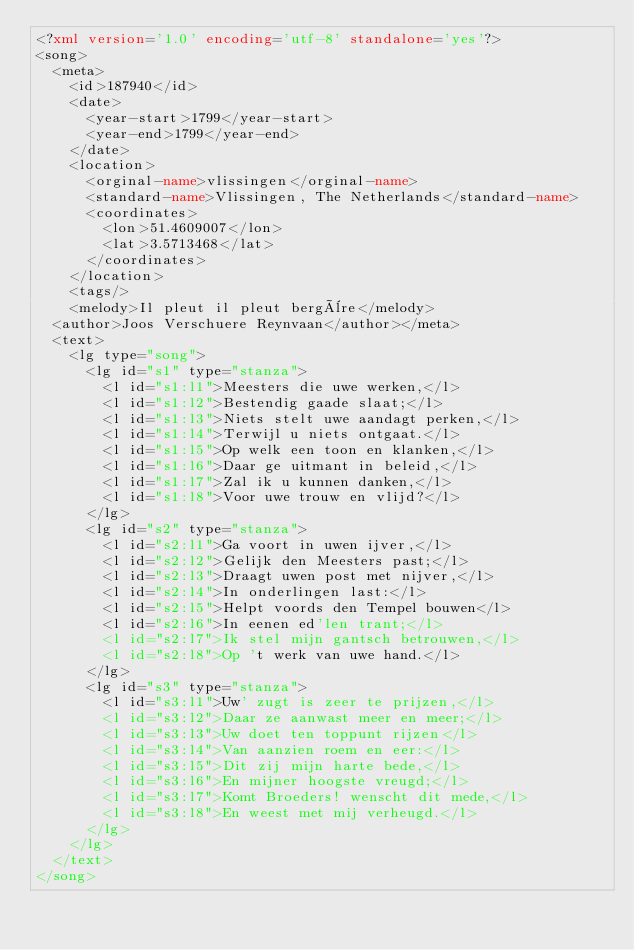<code> <loc_0><loc_0><loc_500><loc_500><_XML_><?xml version='1.0' encoding='utf-8' standalone='yes'?>
<song>
  <meta>
    <id>187940</id>
    <date>
      <year-start>1799</year-start>
      <year-end>1799</year-end>
    </date>
    <location>
      <orginal-name>vlissingen</orginal-name>
      <standard-name>Vlissingen, The Netherlands</standard-name>
      <coordinates>
        <lon>51.4609007</lon>
        <lat>3.5713468</lat>
      </coordinates>
    </location>
    <tags/>
    <melody>Il pleut il pleut bergère</melody>
  <author>Joos Verschuere Reynvaan</author></meta>
  <text>
    <lg type="song">
      <lg id="s1" type="stanza">
        <l id="s1:l1">Meesters die uwe werken,</l>
        <l id="s1:l2">Bestendig gaade slaat;</l>
        <l id="s1:l3">Niets stelt uwe aandagt perken,</l>
        <l id="s1:l4">Terwijl u niets ontgaat.</l>
        <l id="s1:l5">Op welk een toon en klanken,</l>
        <l id="s1:l6">Daar ge uitmant in beleid,</l>
        <l id="s1:l7">Zal ik u kunnen danken,</l>
        <l id="s1:l8">Voor uwe trouw en vlijd?</l>
      </lg>
      <lg id="s2" type="stanza">
        <l id="s2:l1">Ga voort in uwen ijver,</l>
        <l id="s2:l2">Gelijk den Meesters past;</l>
        <l id="s2:l3">Draagt uwen post met nijver,</l>
        <l id="s2:l4">In onderlingen last:</l>
        <l id="s2:l5">Helpt voords den Tempel bouwen</l>
        <l id="s2:l6">In eenen ed'len trant;</l>
        <l id="s2:l7">Ik stel mijn gantsch betrouwen,</l>
        <l id="s2:l8">Op 't werk van uwe hand.</l>
      </lg>
      <lg id="s3" type="stanza">
        <l id="s3:l1">Uw' zugt is zeer te prijzen,</l>
        <l id="s3:l2">Daar ze aanwast meer en meer;</l>
        <l id="s3:l3">Uw doet ten toppunt rijzen</l>
        <l id="s3:l4">Van aanzien roem en eer:</l>
        <l id="s3:l5">Dit zij mijn harte bede,</l>
        <l id="s3:l6">En mijner hoogste vreugd;</l>
        <l id="s3:l7">Komt Broeders! wenscht dit mede,</l>
        <l id="s3:l8">En weest met mij verheugd.</l>
      </lg>
    </lg>
  </text>
</song>
</code> 